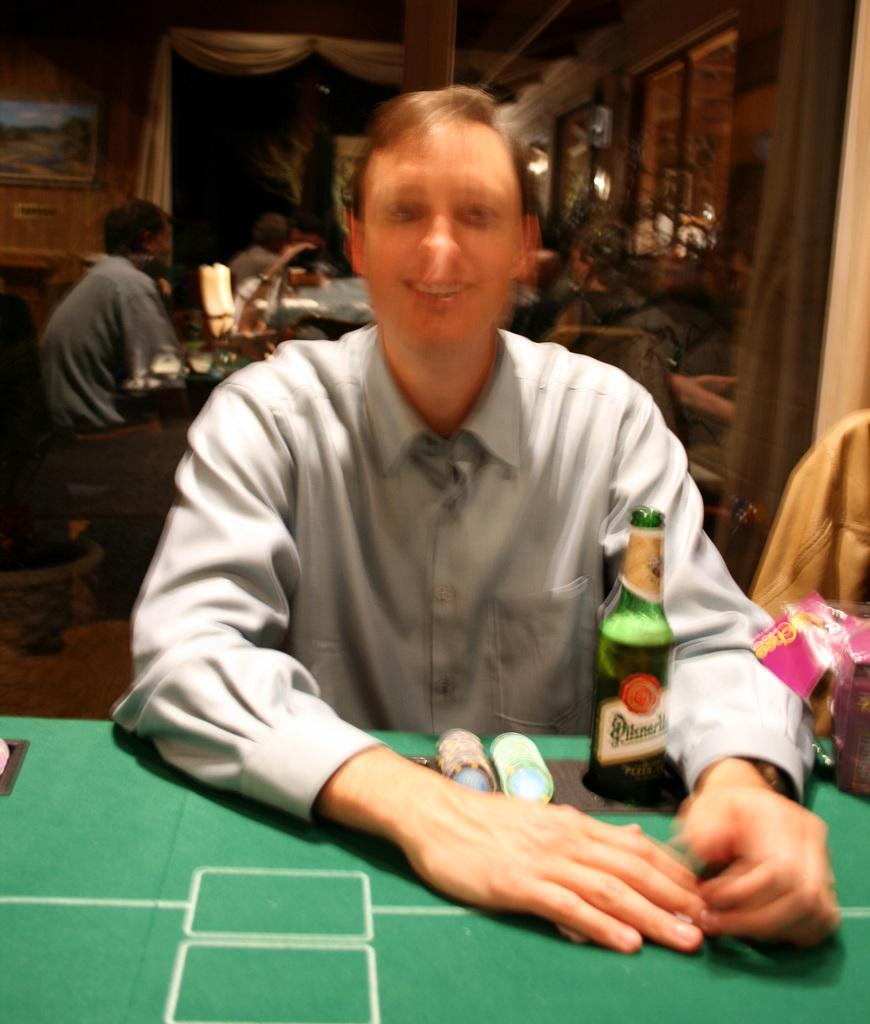Who is present in the image? There is a man in the image. What is the man doing in the image? The man is smiling in the image. What objects can be seen in the image besides the man? There are coins and a bottle in the image. What can be seen in the background of the image? There are people and a wall in the background of the image. What type of rod is the man using to knit wool in the image? There is no rod or wool present in the image, and the man is not knitting. 